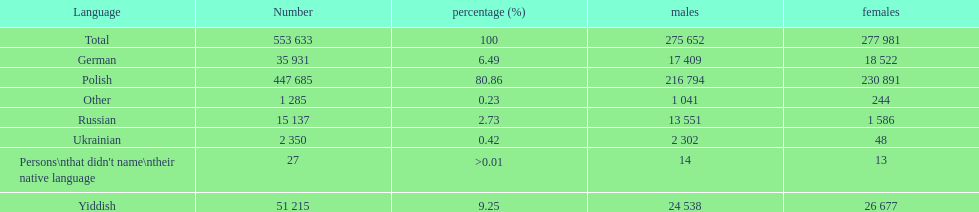How many speakers are represented in polish? 447 685. How many represented speakers are yiddish? 51 215. What is the total number of speakers? 553 633. 